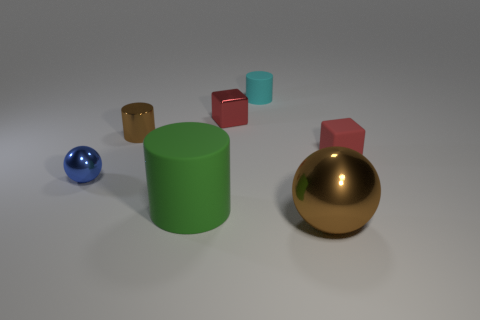How many small blue objects have the same shape as the cyan rubber thing?
Your answer should be very brief. 0. How many small things are on the left side of the brown shiny ball and behind the blue shiny ball?
Provide a short and direct response. 3. The tiny metal cylinder has what color?
Offer a terse response. Brown. Is there a red cube made of the same material as the small blue ball?
Your answer should be compact. Yes. Are there any red matte objects in front of the metal ball on the right side of the brown shiny object behind the large green rubber cylinder?
Give a very brief answer. No. There is a small metallic cylinder; are there any metallic balls on the left side of it?
Make the answer very short. Yes. Is there a shiny object that has the same color as the small matte cube?
Provide a succinct answer. Yes. How many tiny objects are either metal objects or brown objects?
Offer a terse response. 3. Are the red block to the right of the cyan matte cylinder and the large green object made of the same material?
Offer a terse response. Yes. There is a thing that is behind the tiny red thing that is on the left side of the small block that is right of the red metal thing; what shape is it?
Your response must be concise. Cylinder. 